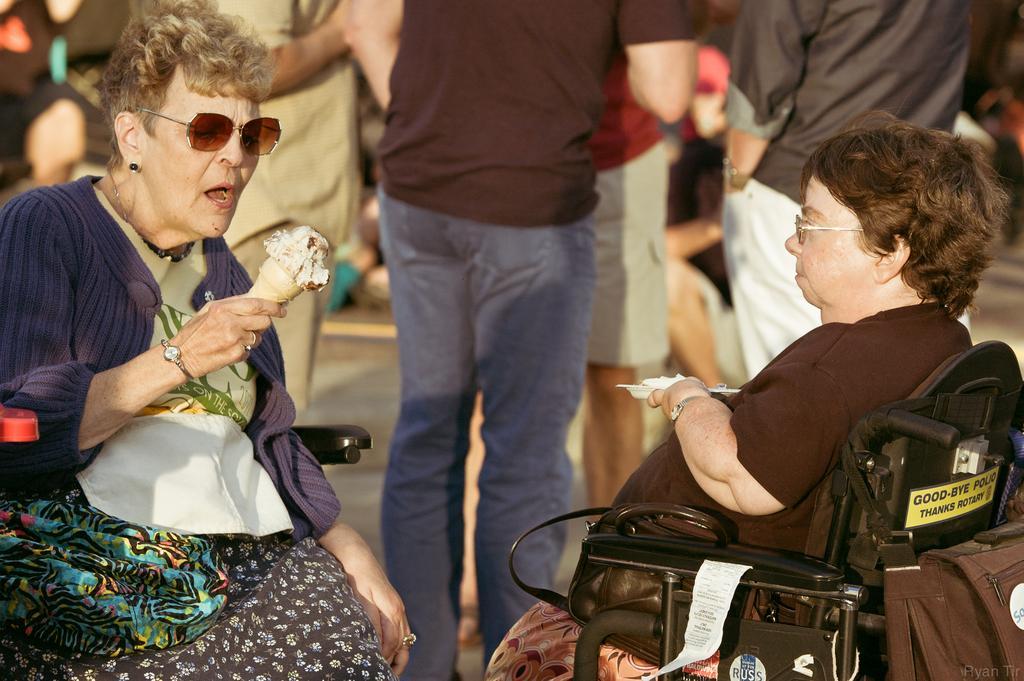Could you give a brief overview of what you see in this image? On the left corner of the picture, we see woman in white T-shirt and blue jacket who is sitting on the chair is holding ice cream in her hands and on the right corner of the picture, woman in black t-shirt is holding plate in her hand. In the middle of the picture, we see many people standing. 